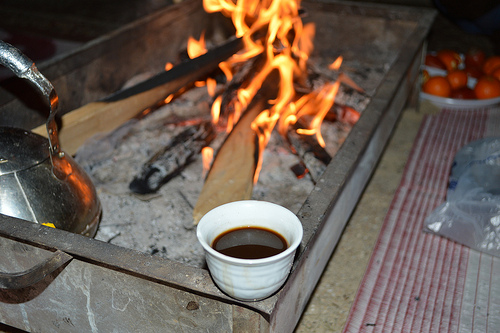<image>
Can you confirm if the cup is in the fire? No. The cup is not contained within the fire. These objects have a different spatial relationship. Is there a kettle on the fire? No. The kettle is not positioned on the fire. They may be near each other, but the kettle is not supported by or resting on top of the fire. 